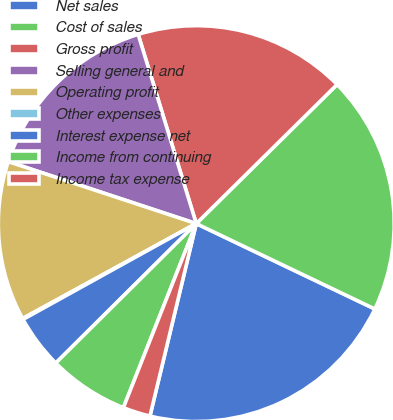Convert chart. <chart><loc_0><loc_0><loc_500><loc_500><pie_chart><fcel>Net sales<fcel>Cost of sales<fcel>Gross profit<fcel>Selling general and<fcel>Operating profit<fcel>Other expenses<fcel>Interest expense net<fcel>Income from continuing<fcel>Income tax expense<nl><fcel>21.66%<fcel>19.5%<fcel>17.34%<fcel>15.19%<fcel>13.03%<fcel>0.08%<fcel>4.4%<fcel>6.56%<fcel>2.24%<nl></chart> 